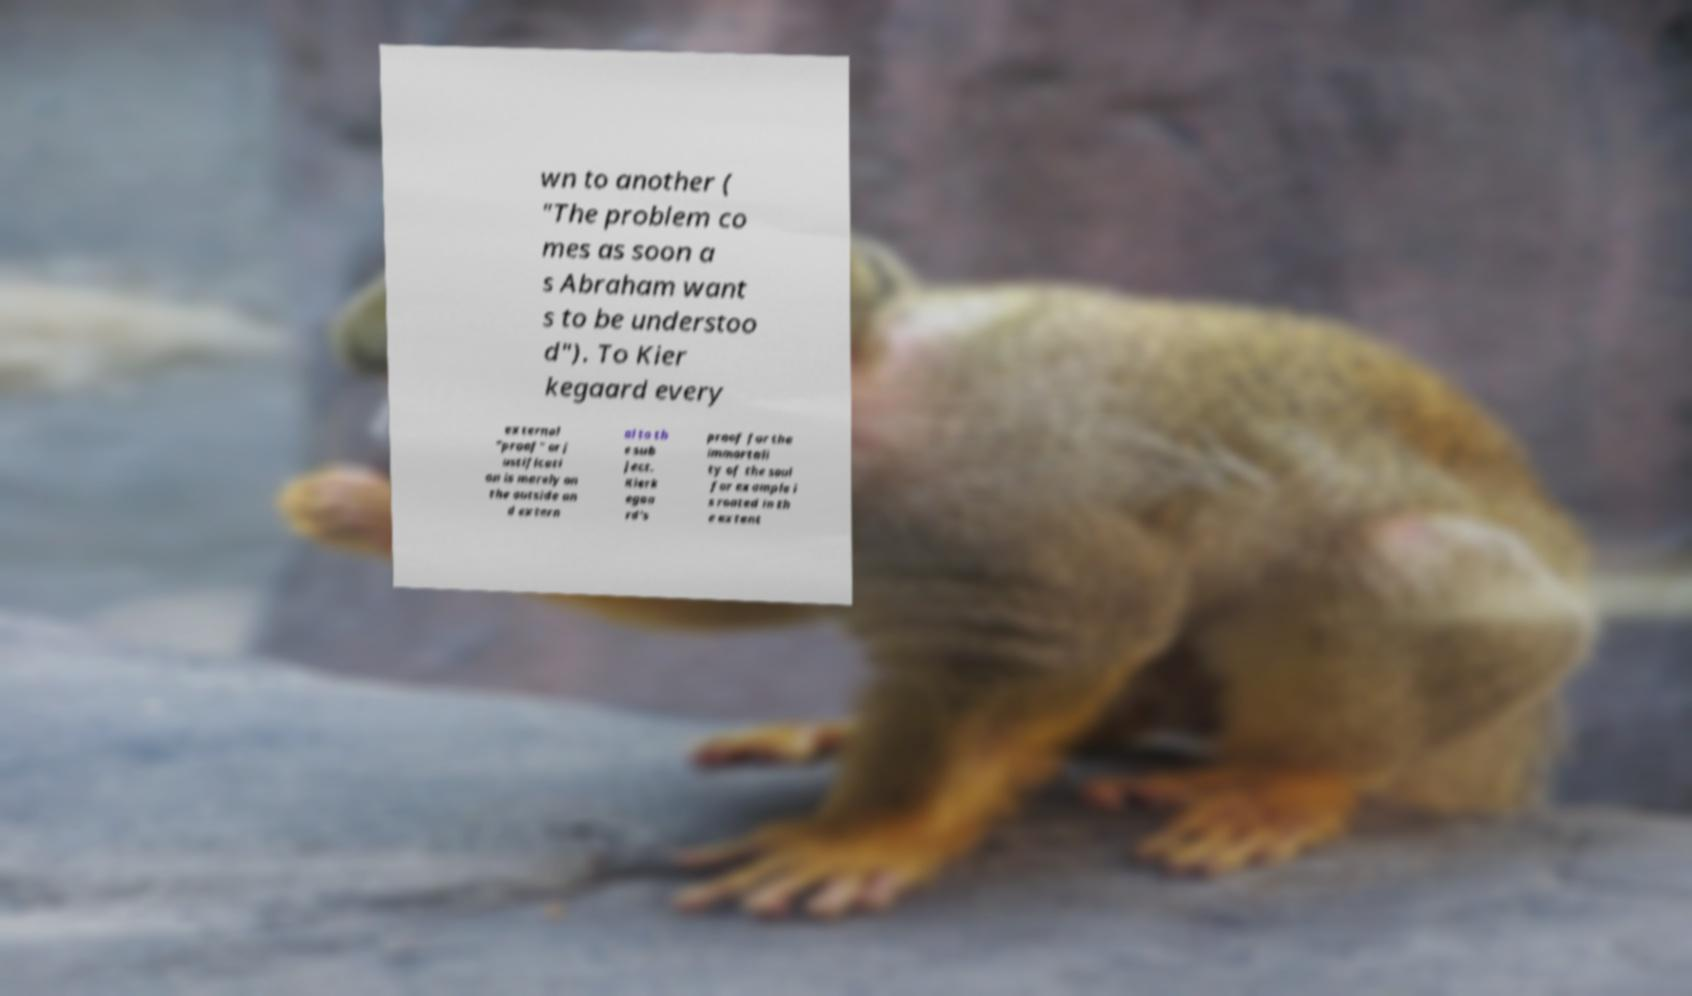Could you extract and type out the text from this image? wn to another ( "The problem co mes as soon a s Abraham want s to be understoo d"). To Kier kegaard every external "proof" or j ustificati on is merely on the outside an d extern al to th e sub ject. Kierk egaa rd's proof for the immortali ty of the soul for example i s rooted in th e extent 